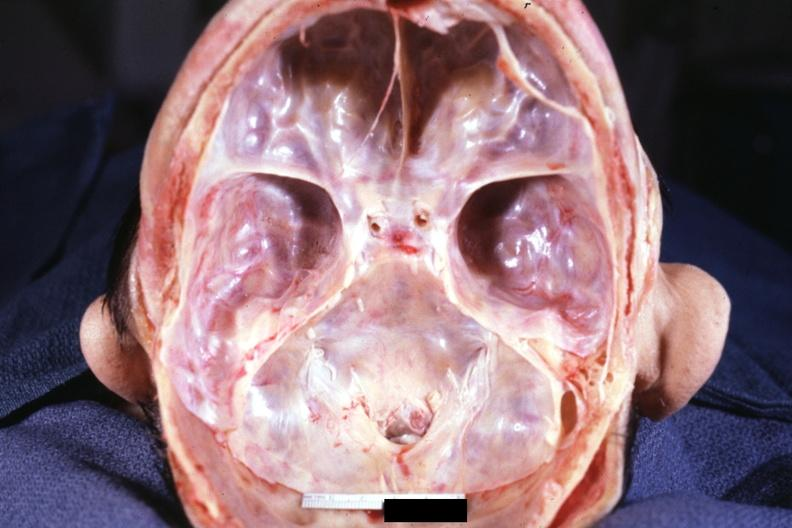what is present?
Answer the question using a single word or phrase. Rheumatoid arthritis 